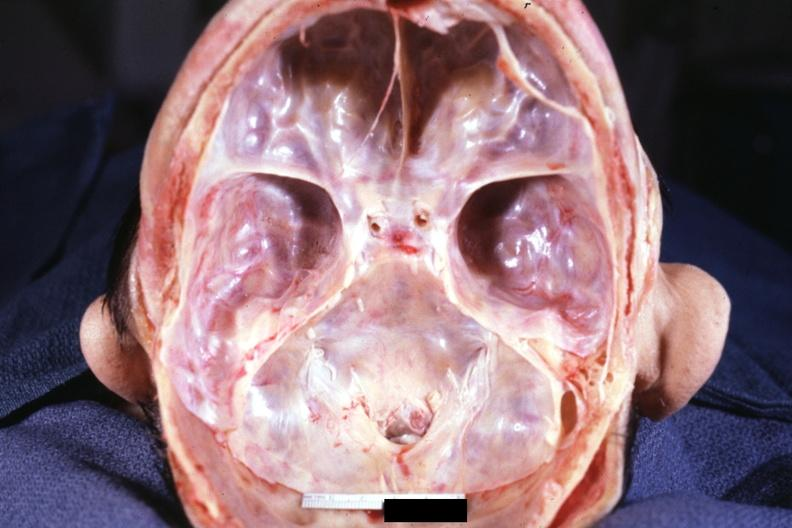what is present?
Answer the question using a single word or phrase. Rheumatoid arthritis 